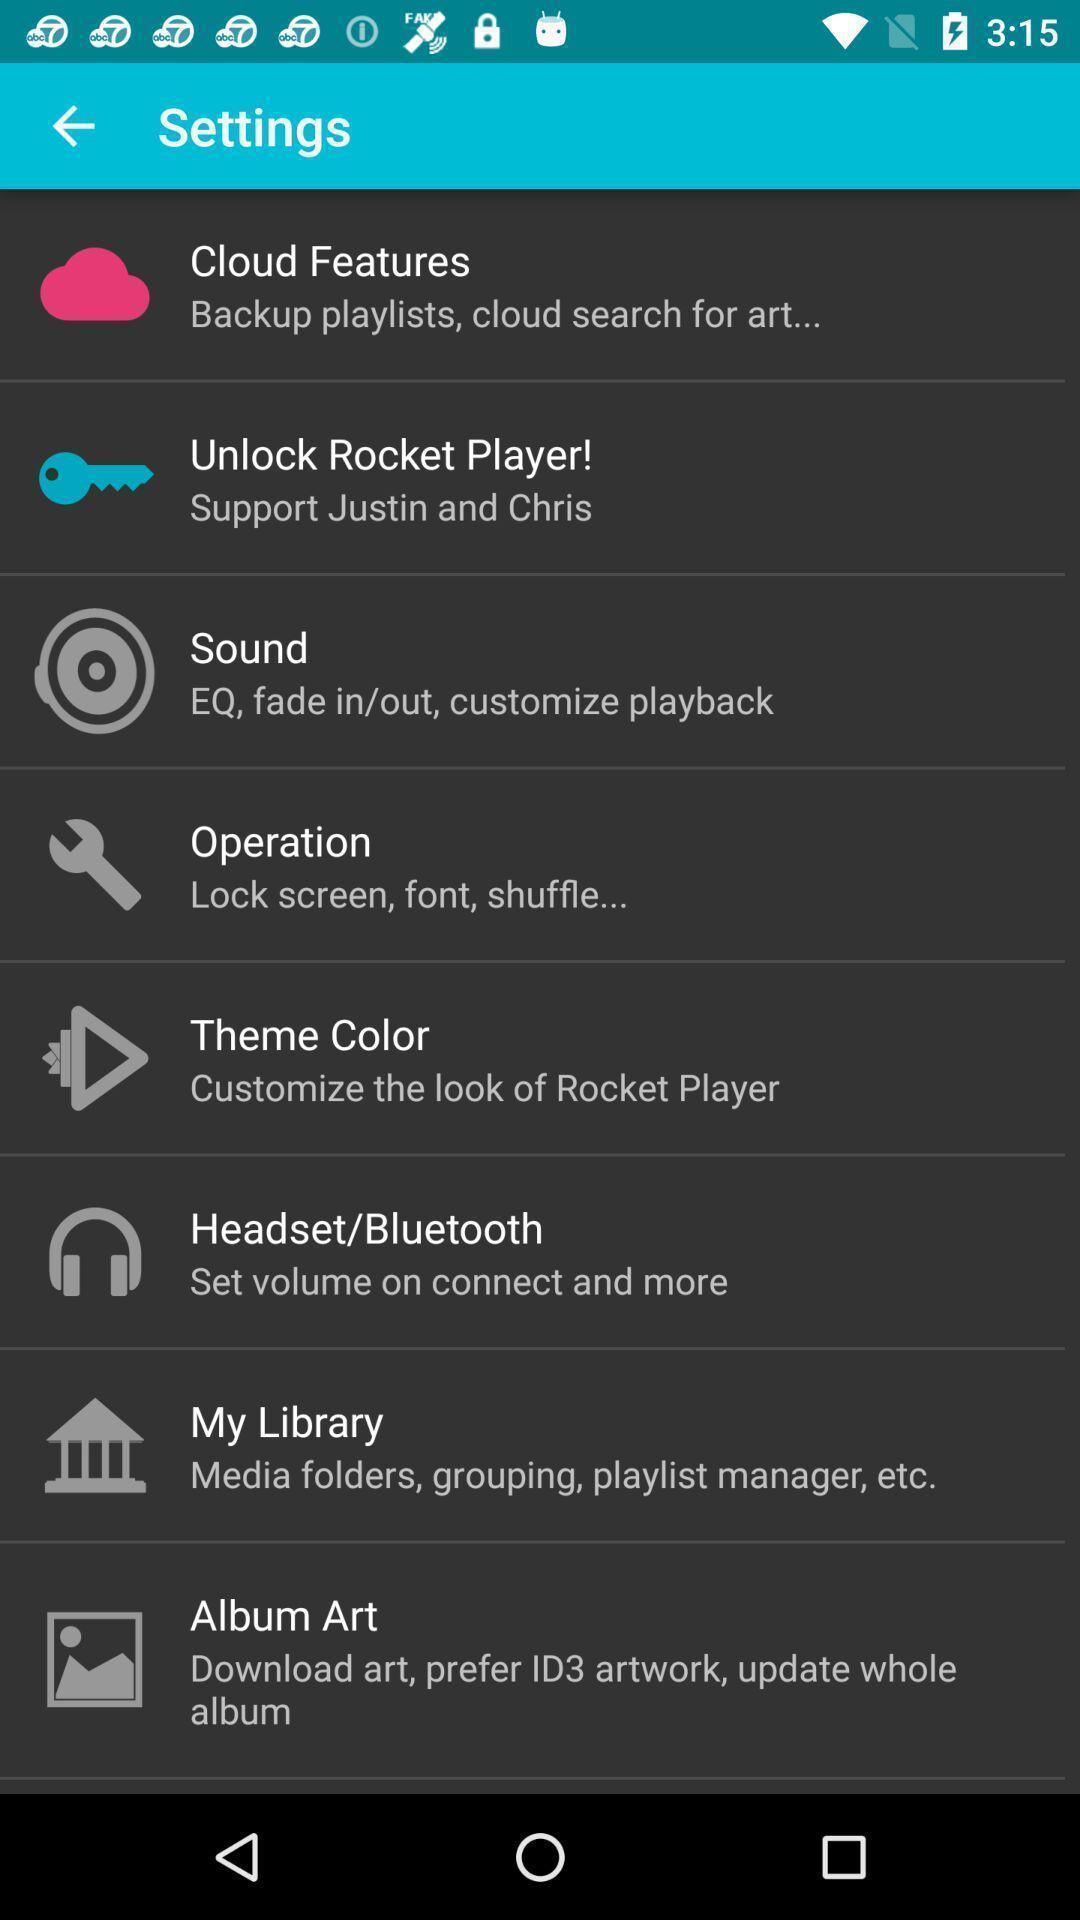Describe the visual elements of this screenshot. Page showing different options in settings. 